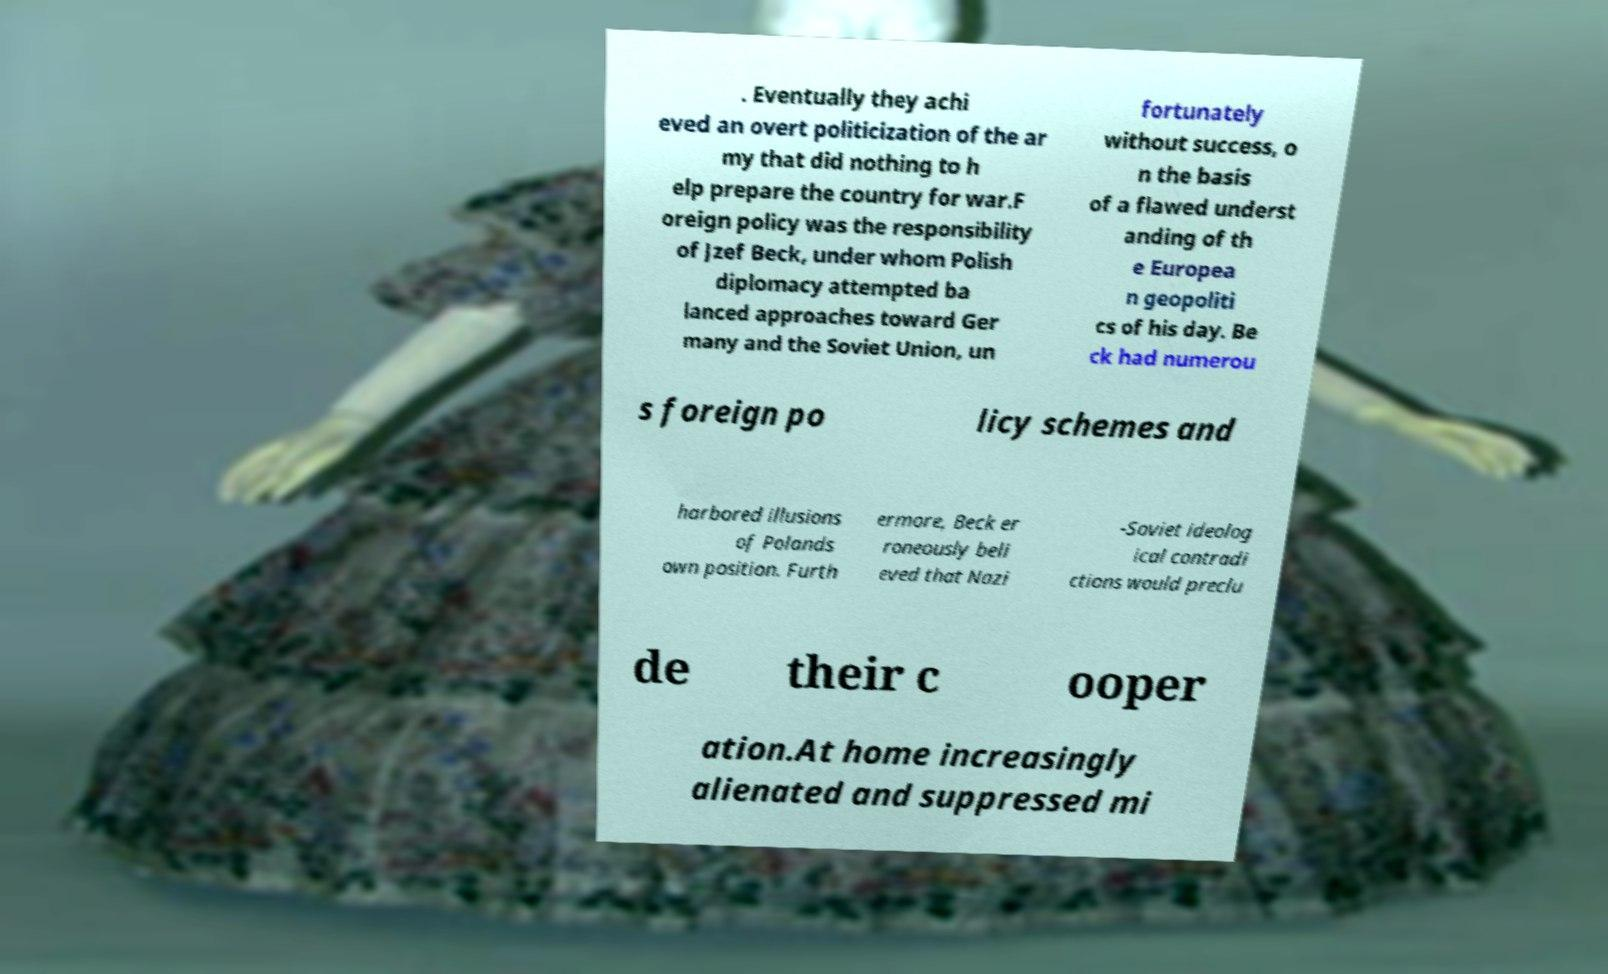Can you read and provide the text displayed in the image?This photo seems to have some interesting text. Can you extract and type it out for me? . Eventually they achi eved an overt politicization of the ar my that did nothing to h elp prepare the country for war.F oreign policy was the responsibility of Jzef Beck, under whom Polish diplomacy attempted ba lanced approaches toward Ger many and the Soviet Union, un fortunately without success, o n the basis of a flawed underst anding of th e Europea n geopoliti cs of his day. Be ck had numerou s foreign po licy schemes and harbored illusions of Polands own position. Furth ermore, Beck er roneously beli eved that Nazi -Soviet ideolog ical contradi ctions would preclu de their c ooper ation.At home increasingly alienated and suppressed mi 